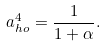Convert formula to latex. <formula><loc_0><loc_0><loc_500><loc_500>a _ { h o } ^ { 4 } = \frac { 1 } { 1 + \alpha } .</formula> 